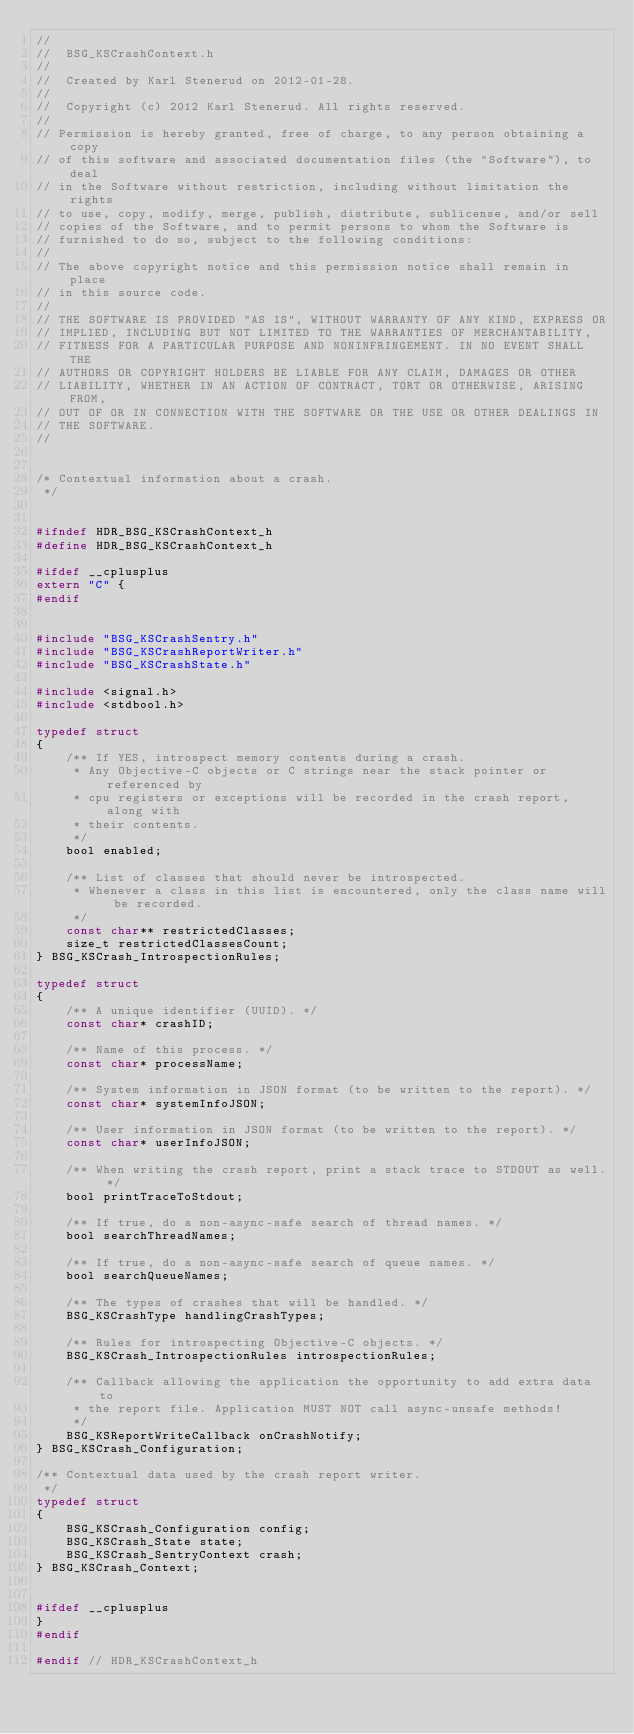Convert code to text. <code><loc_0><loc_0><loc_500><loc_500><_C_>//
//  BSG_KSCrashContext.h
//
//  Created by Karl Stenerud on 2012-01-28.
//
//  Copyright (c) 2012 Karl Stenerud. All rights reserved.
//
// Permission is hereby granted, free of charge, to any person obtaining a copy
// of this software and associated documentation files (the "Software"), to deal
// in the Software without restriction, including without limitation the rights
// to use, copy, modify, merge, publish, distribute, sublicense, and/or sell
// copies of the Software, and to permit persons to whom the Software is
// furnished to do so, subject to the following conditions:
//
// The above copyright notice and this permission notice shall remain in place
// in this source code.
//
// THE SOFTWARE IS PROVIDED "AS IS", WITHOUT WARRANTY OF ANY KIND, EXPRESS OR
// IMPLIED, INCLUDING BUT NOT LIMITED TO THE WARRANTIES OF MERCHANTABILITY,
// FITNESS FOR A PARTICULAR PURPOSE AND NONINFRINGEMENT. IN NO EVENT SHALL THE
// AUTHORS OR COPYRIGHT HOLDERS BE LIABLE FOR ANY CLAIM, DAMAGES OR OTHER
// LIABILITY, WHETHER IN AN ACTION OF CONTRACT, TORT OR OTHERWISE, ARISING FROM,
// OUT OF OR IN CONNECTION WITH THE SOFTWARE OR THE USE OR OTHER DEALINGS IN
// THE SOFTWARE.
//


/* Contextual information about a crash.
 */


#ifndef HDR_BSG_KSCrashContext_h
#define HDR_BSG_KSCrashContext_h

#ifdef __cplusplus
extern "C" {
#endif


#include "BSG_KSCrashSentry.h"
#include "BSG_KSCrashReportWriter.h"
#include "BSG_KSCrashState.h"

#include <signal.h>
#include <stdbool.h>

typedef struct
{
    /** If YES, introspect memory contents during a crash.
     * Any Objective-C objects or C strings near the stack pointer or referenced by
     * cpu registers or exceptions will be recorded in the crash report, along with
     * their contents.
     */
    bool enabled;
    
    /** List of classes that should never be introspected.
     * Whenever a class in this list is encountered, only the class name will be recorded.
     */
    const char** restrictedClasses;
    size_t restrictedClassesCount;
} BSG_KSCrash_IntrospectionRules;

typedef struct
{
    /** A unique identifier (UUID). */
    const char* crashID;

    /** Name of this process. */
    const char* processName;

    /** System information in JSON format (to be written to the report). */
    const char* systemInfoJSON;

    /** User information in JSON format (to be written to the report). */
    const char* userInfoJSON;

    /** When writing the crash report, print a stack trace to STDOUT as well. */
    bool printTraceToStdout;

    /** If true, do a non-async-safe search of thread names. */
    bool searchThreadNames;

    /** If true, do a non-async-safe search of queue names. */
    bool searchQueueNames;

    /** The types of crashes that will be handled. */
    BSG_KSCrashType handlingCrashTypes;

    /** Rules for introspecting Objective-C objects. */
    BSG_KSCrash_IntrospectionRules introspectionRules;
    
    /** Callback allowing the application the opportunity to add extra data to
     * the report file. Application MUST NOT call async-unsafe methods!
     */
    BSG_KSReportWriteCallback onCrashNotify;
} BSG_KSCrash_Configuration;

/** Contextual data used by the crash report writer.
 */
typedef struct
{
    BSG_KSCrash_Configuration config;
    BSG_KSCrash_State state;
    BSG_KSCrash_SentryContext crash;
} BSG_KSCrash_Context;


#ifdef __cplusplus
}
#endif

#endif // HDR_KSCrashContext_h
</code> 